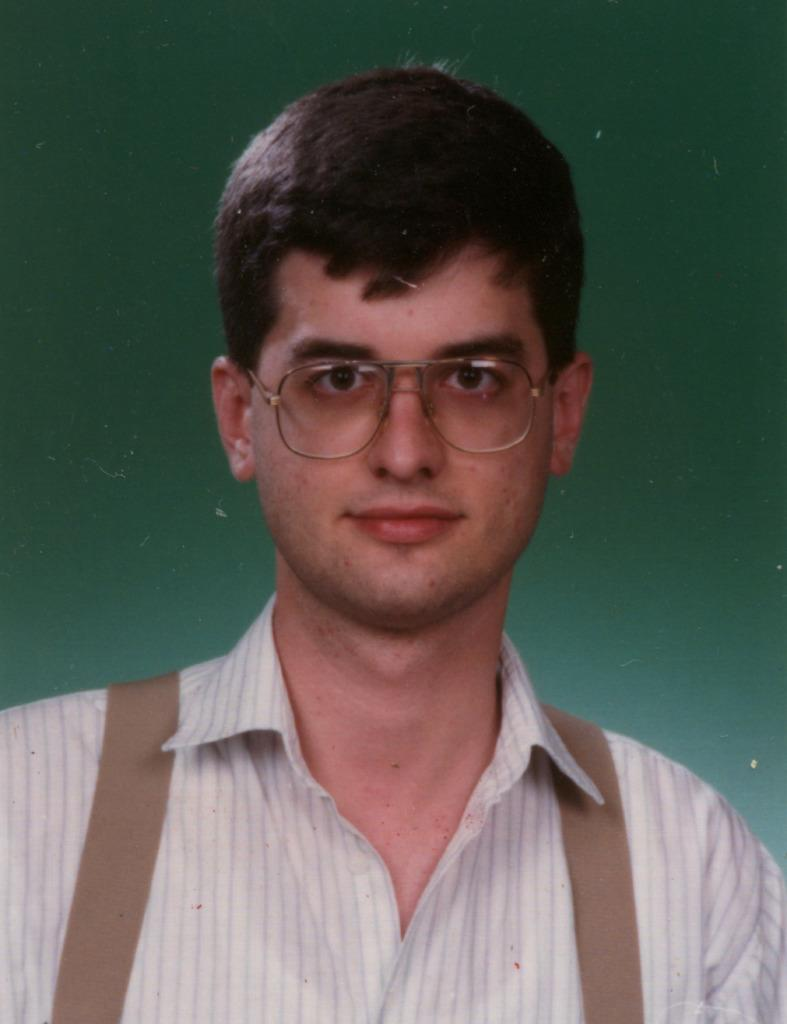What is present in the image? There is a person in the image. What is the person wearing? The person is wearing a shirt and spectacles. What is the person's facial expression? The person is smiling. What is the person doing in the image? The person is watching something. What color is the background of the image? The background of the image is green in color. How does the person measure the distance between the window and the wall in the image? There is no window or measuring activity present in the image. 